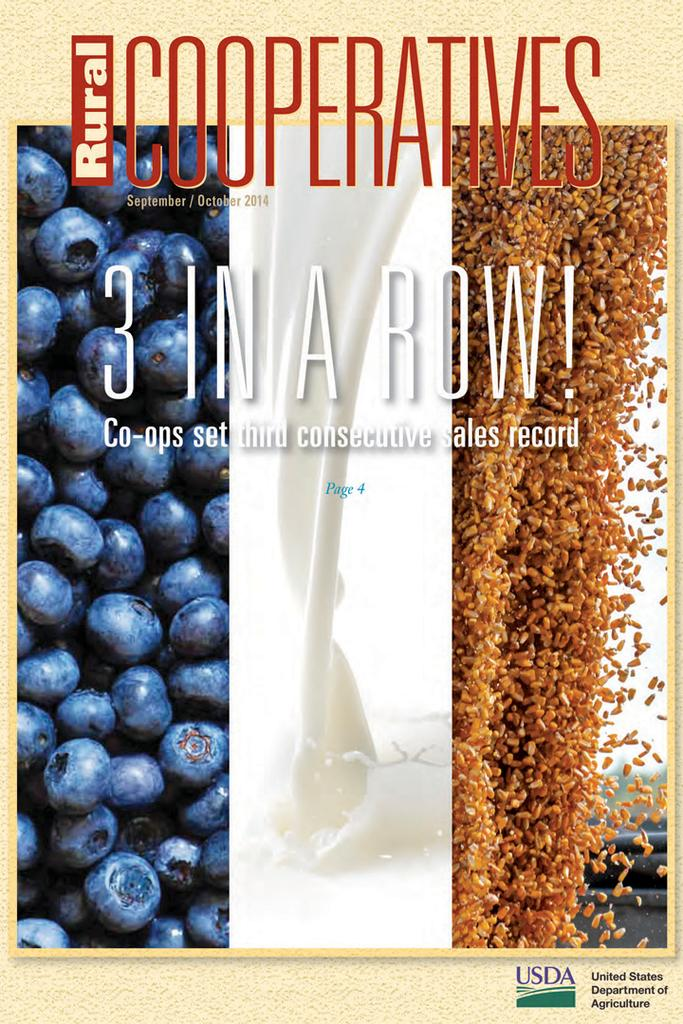<image>
Describe the image concisely. A poster by the USDA for Rural Cooperatives has blueberries, milk, and seeds on the front 